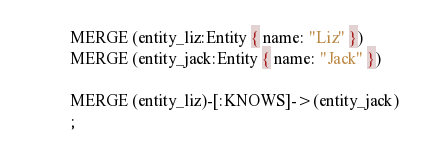Convert code to text. <code><loc_0><loc_0><loc_500><loc_500><_SQL_>MERGE (entity_liz:Entity { name: "Liz" })
MERGE (entity_jack:Entity { name: "Jack" })

MERGE (entity_liz)-[:KNOWS]->(entity_jack)
;
</code> 